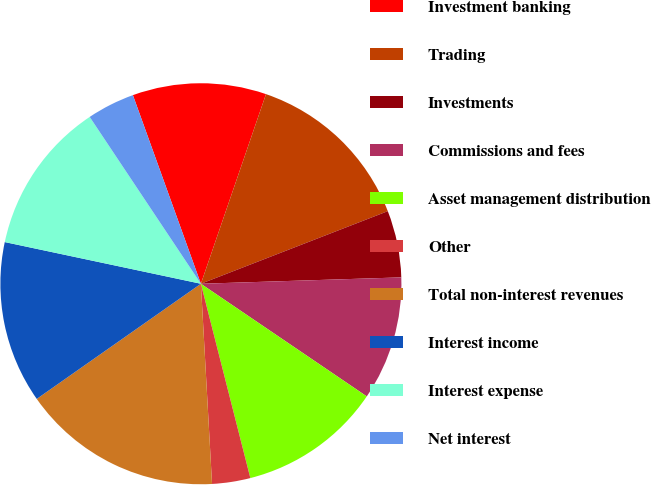Convert chart. <chart><loc_0><loc_0><loc_500><loc_500><pie_chart><fcel>Investment banking<fcel>Trading<fcel>Investments<fcel>Commissions and fees<fcel>Asset management distribution<fcel>Other<fcel>Total non-interest revenues<fcel>Interest income<fcel>Interest expense<fcel>Net interest<nl><fcel>10.77%<fcel>13.84%<fcel>5.39%<fcel>10.0%<fcel>11.54%<fcel>3.08%<fcel>16.15%<fcel>13.07%<fcel>12.31%<fcel>3.85%<nl></chart> 